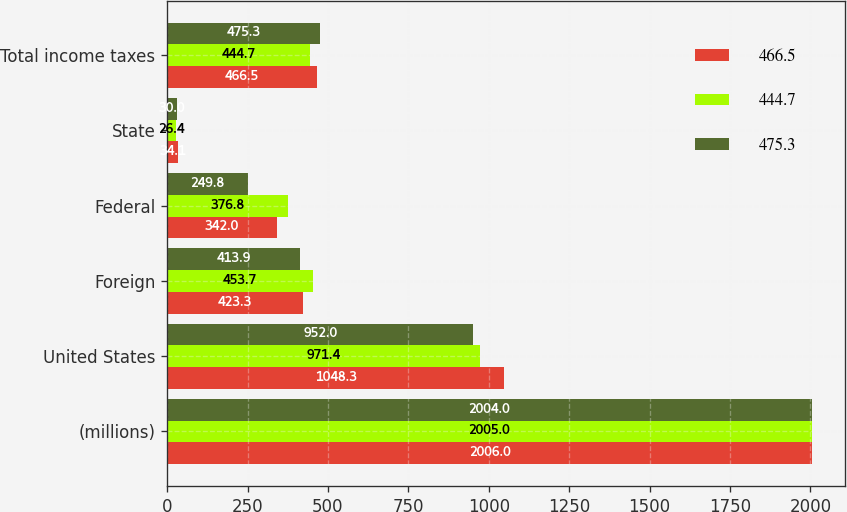<chart> <loc_0><loc_0><loc_500><loc_500><stacked_bar_chart><ecel><fcel>(millions)<fcel>United States<fcel>Foreign<fcel>Federal<fcel>State<fcel>Total income taxes<nl><fcel>466.5<fcel>2006<fcel>1048.3<fcel>423.3<fcel>342<fcel>34.1<fcel>466.5<nl><fcel>444.7<fcel>2005<fcel>971.4<fcel>453.7<fcel>376.8<fcel>26.4<fcel>444.7<nl><fcel>475.3<fcel>2004<fcel>952<fcel>413.9<fcel>249.8<fcel>30<fcel>475.3<nl></chart> 